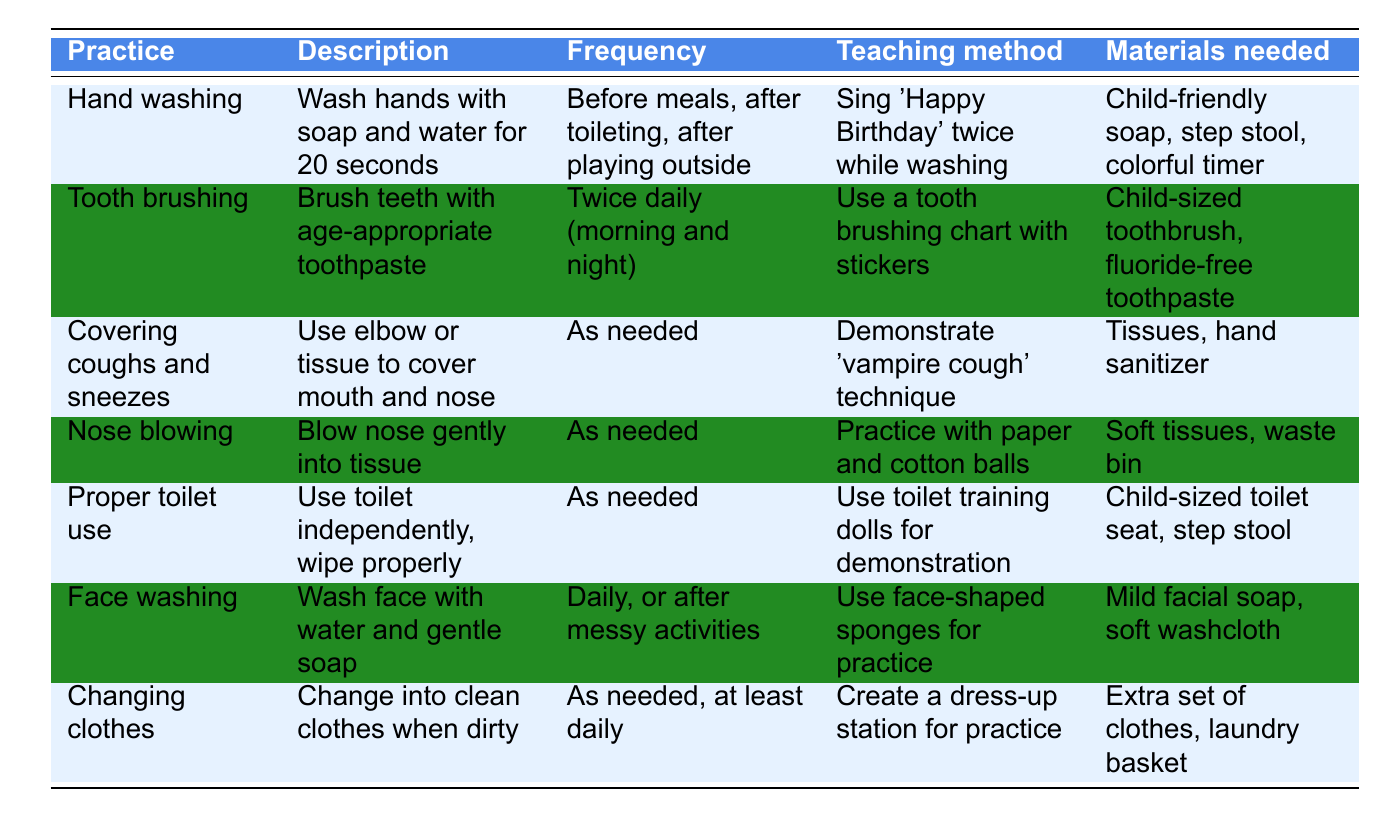What hygienic practice happens twice a day? The table indicates that "Tooth brushing" occurs twice daily, which is stated in the "Frequency" column.
Answer: Tooth brushing How often should preschoolers wash their hands? The table specifies that hand washing should be done before meals, after toileting, and after playing outside, indicating it may happen multiple times a day.
Answer: Before meals, after toileting, after playing outside What is the teaching method for covering coughs and sneezes? According to the table, the method is to demonstrate the 'vampire cough' technique.
Answer: Demonstrate 'vampire cough' technique Which practices require materials to practice? The practices that require materials to practice include nose blowing, face washing, proper toilet use, and changing clothes, as they all list specific materials needed for practice in the table.
Answer: Nose blowing, face washing, proper toilet use, changing clothes How many hygiene practices are listed in the table? The table lists a total of 7 hygiene practices. By counting each row of practices, we find there are 7 entries.
Answer: 7 Is the use of tissues needed for both covering coughs and sneezes and nose blowing? Yes, the table confirms that tissues are needed as materials for both "Covering coughs and sneezes" and "Nose blowing," indicating a common material requirement.
Answer: Yes What is the purpose of the step stool in the hygiene practices? The table mentions that a step stool is listed as a material needed for both hand washing and proper toilet use, indicating it assists preschoolers in reaching the sink or toilet.
Answer: To assist in reaching the sink or toilet How does the teaching method for face washing differ from that of tooth brushing? The face washing method uses face-shaped sponges for practice while the tooth brushing method involves a brushing chart with stickers, highlighting different engagement strategies.
Answer: Different engagement strategies Which hygiene practice's description emphasizes gentle action, and what does it entail? The hygiene practice "Nose blowing" emphasizes gentle action, stating to blow the nose gently into a tissue.
Answer: Nose blowing, blow gently into tissue What frequency of changing clothes is specified for preschoolers? The table specifies that changing clothes should happen as needed, but at least daily, indicating a regular habit to ensure cleanliness.
Answer: As needed, at least daily What are the materials needed for proper toilet use? For proper toilet use, the table lists a child-sized toilet seat and a step stool as necessary materials.
Answer: Child-sized toilet seat, step stool 